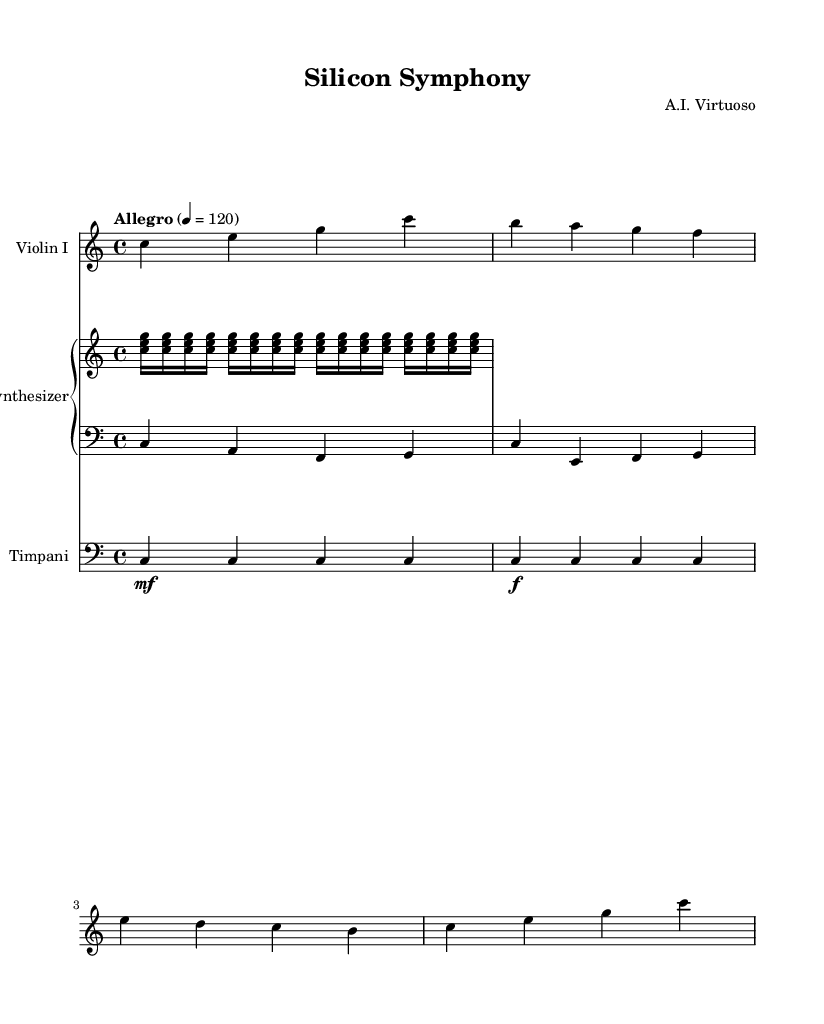What is the key signature of this music? The key signature is C major, which has no sharps or flats.
Answer: C major What is the time signature of the piece? The time signature is 4/4, indicating four beats in a measure.
Answer: 4/4 What is the tempo marking indicated in the score? The tempo marking is "Allegro," which means to be played at a fast tempo.
Answer: Allegro How many measures are in the violin part? The violin part has 4 measures, as indicated by the notation.
Answer: 4 What is the dynamic marking for the Timpani in the first measure? The dynamic marking for the Timpani in the first measure is mezzo-forte, which means moderately loud.
Answer: mezzo-forte How many notes are played in the synthesizer's upper staff during the repeat? The synthesizer's upper staff plays 16 notes during the repeat section (4 sets of 4).
Answer: 16 What instruments are involved in this piece? The piece includes Violin I, Synthesizer (with both upper and lower staff), and Timpani.
Answer: Violin I, Synthesizer, Timpani 